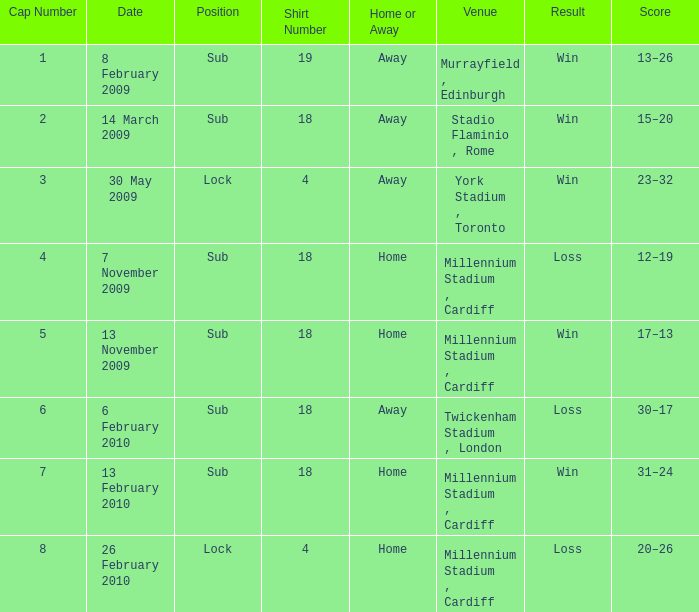Can you tell me the lowest Cap Number that has the Date of 8 february 2009, and the Shirt Number larger than 19? None. 